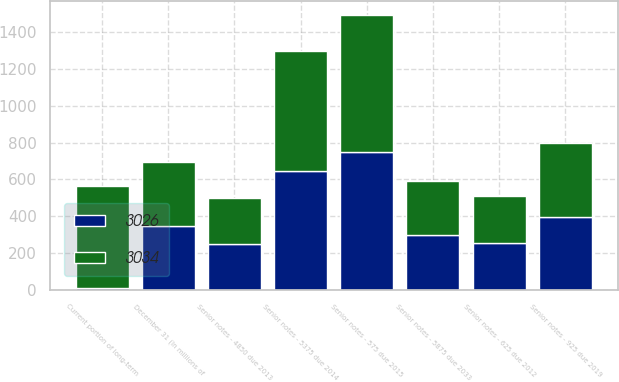<chart> <loc_0><loc_0><loc_500><loc_500><stacked_bar_chart><ecel><fcel>December 31 (In millions of<fcel>Current portion of long-term<fcel>Senior notes - 625 due 2012<fcel>Senior notes - 4850 due 2013<fcel>Senior notes - 5875 due 2033<fcel>Senior notes - 5375 due 2014<fcel>Senior notes - 575 due 2015<fcel>Senior notes - 925 due 2019<nl><fcel>3026<fcel>347<fcel>8<fcel>253<fcel>250<fcel>296<fcel>648<fcel>747<fcel>398<nl><fcel>3034<fcel>347<fcel>558<fcel>255<fcel>249<fcel>296<fcel>648<fcel>747<fcel>398<nl></chart> 